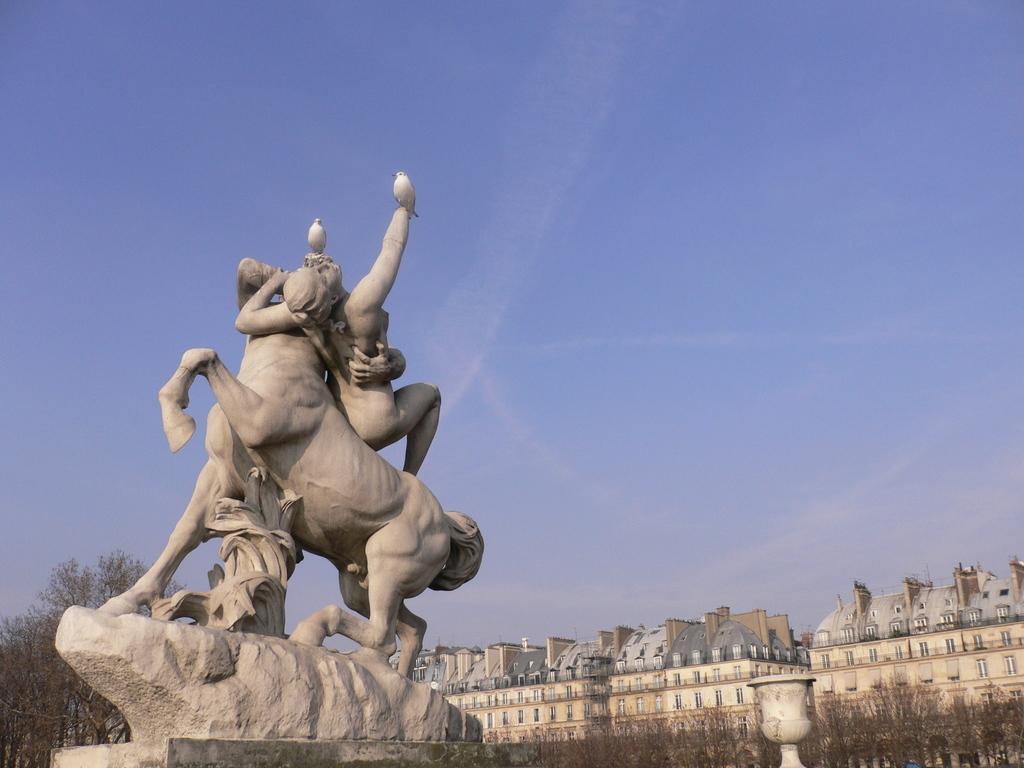Describe this image in one or two sentences. In this picture, there is a statue towards the left. On the statue, there are two birds. At the bottom right, there are buildings and trees. On the top, there is a sky with clouds. 